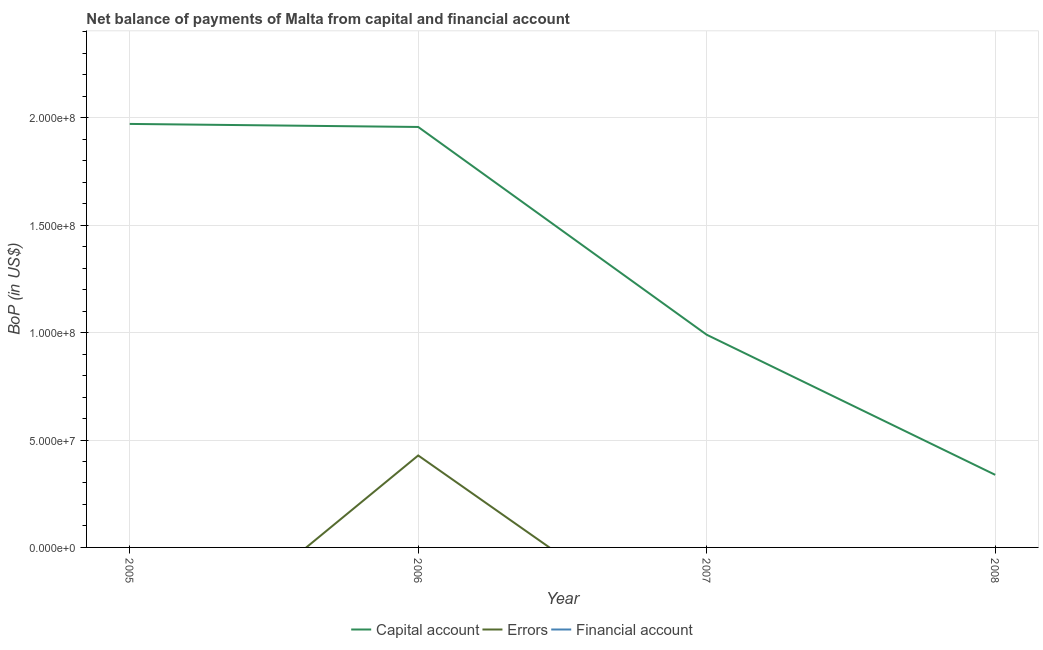How many different coloured lines are there?
Keep it short and to the point. 2. What is the amount of errors in 2006?
Your answer should be compact. 4.28e+07. Across all years, what is the maximum amount of net capital account?
Offer a terse response. 1.97e+08. In which year was the amount of net capital account maximum?
Ensure brevity in your answer.  2005. What is the total amount of net capital account in the graph?
Your answer should be very brief. 5.26e+08. What is the difference between the amount of net capital account in 2006 and that in 2008?
Offer a very short reply. 1.62e+08. What is the difference between the amount of errors in 2007 and the amount of net capital account in 2005?
Provide a succinct answer. -1.97e+08. What is the average amount of net capital account per year?
Your response must be concise. 1.31e+08. In the year 2006, what is the difference between the amount of errors and amount of net capital account?
Give a very brief answer. -1.53e+08. What is the ratio of the amount of net capital account in 2007 to that in 2008?
Your answer should be compact. 2.93. What is the difference between the highest and the second highest amount of net capital account?
Make the answer very short. 1.42e+06. What is the difference between the highest and the lowest amount of net capital account?
Offer a terse response. 1.63e+08. In how many years, is the amount of financial account greater than the average amount of financial account taken over all years?
Provide a short and direct response. 0. Is the sum of the amount of net capital account in 2006 and 2008 greater than the maximum amount of financial account across all years?
Keep it short and to the point. Yes. Is it the case that in every year, the sum of the amount of net capital account and amount of errors is greater than the amount of financial account?
Make the answer very short. Yes. Is the amount of errors strictly less than the amount of net capital account over the years?
Provide a succinct answer. Yes. What is the difference between two consecutive major ticks on the Y-axis?
Ensure brevity in your answer.  5.00e+07. Are the values on the major ticks of Y-axis written in scientific E-notation?
Make the answer very short. Yes. Does the graph contain any zero values?
Offer a terse response. Yes. Where does the legend appear in the graph?
Your answer should be very brief. Bottom center. How are the legend labels stacked?
Give a very brief answer. Horizontal. What is the title of the graph?
Offer a very short reply. Net balance of payments of Malta from capital and financial account. Does "Negligence towards kids" appear as one of the legend labels in the graph?
Provide a succinct answer. No. What is the label or title of the Y-axis?
Provide a short and direct response. BoP (in US$). What is the BoP (in US$) of Capital account in 2005?
Offer a very short reply. 1.97e+08. What is the BoP (in US$) of Capital account in 2006?
Offer a terse response. 1.96e+08. What is the BoP (in US$) in Errors in 2006?
Your response must be concise. 4.28e+07. What is the BoP (in US$) of Capital account in 2007?
Your answer should be compact. 9.90e+07. What is the BoP (in US$) of Errors in 2007?
Give a very brief answer. 0. What is the BoP (in US$) of Capital account in 2008?
Offer a terse response. 3.38e+07. What is the BoP (in US$) of Errors in 2008?
Ensure brevity in your answer.  0. What is the BoP (in US$) in Financial account in 2008?
Provide a short and direct response. 0. Across all years, what is the maximum BoP (in US$) of Capital account?
Keep it short and to the point. 1.97e+08. Across all years, what is the maximum BoP (in US$) in Errors?
Provide a succinct answer. 4.28e+07. Across all years, what is the minimum BoP (in US$) of Capital account?
Keep it short and to the point. 3.38e+07. Across all years, what is the minimum BoP (in US$) in Errors?
Keep it short and to the point. 0. What is the total BoP (in US$) of Capital account in the graph?
Ensure brevity in your answer.  5.26e+08. What is the total BoP (in US$) in Errors in the graph?
Keep it short and to the point. 4.28e+07. What is the difference between the BoP (in US$) of Capital account in 2005 and that in 2006?
Offer a terse response. 1.42e+06. What is the difference between the BoP (in US$) in Capital account in 2005 and that in 2007?
Keep it short and to the point. 9.81e+07. What is the difference between the BoP (in US$) of Capital account in 2005 and that in 2008?
Make the answer very short. 1.63e+08. What is the difference between the BoP (in US$) of Capital account in 2006 and that in 2007?
Offer a very short reply. 9.67e+07. What is the difference between the BoP (in US$) of Capital account in 2006 and that in 2008?
Keep it short and to the point. 1.62e+08. What is the difference between the BoP (in US$) of Capital account in 2007 and that in 2008?
Your answer should be compact. 6.52e+07. What is the difference between the BoP (in US$) in Capital account in 2005 and the BoP (in US$) in Errors in 2006?
Offer a very short reply. 1.54e+08. What is the average BoP (in US$) in Capital account per year?
Make the answer very short. 1.31e+08. What is the average BoP (in US$) in Errors per year?
Give a very brief answer. 1.07e+07. In the year 2006, what is the difference between the BoP (in US$) of Capital account and BoP (in US$) of Errors?
Provide a succinct answer. 1.53e+08. What is the ratio of the BoP (in US$) of Capital account in 2005 to that in 2006?
Make the answer very short. 1.01. What is the ratio of the BoP (in US$) of Capital account in 2005 to that in 2007?
Provide a short and direct response. 1.99. What is the ratio of the BoP (in US$) of Capital account in 2005 to that in 2008?
Your answer should be compact. 5.83. What is the ratio of the BoP (in US$) of Capital account in 2006 to that in 2007?
Provide a succinct answer. 1.98. What is the ratio of the BoP (in US$) of Capital account in 2006 to that in 2008?
Offer a terse response. 5.79. What is the ratio of the BoP (in US$) in Capital account in 2007 to that in 2008?
Your response must be concise. 2.93. What is the difference between the highest and the second highest BoP (in US$) of Capital account?
Keep it short and to the point. 1.42e+06. What is the difference between the highest and the lowest BoP (in US$) in Capital account?
Your answer should be very brief. 1.63e+08. What is the difference between the highest and the lowest BoP (in US$) of Errors?
Your response must be concise. 4.28e+07. 